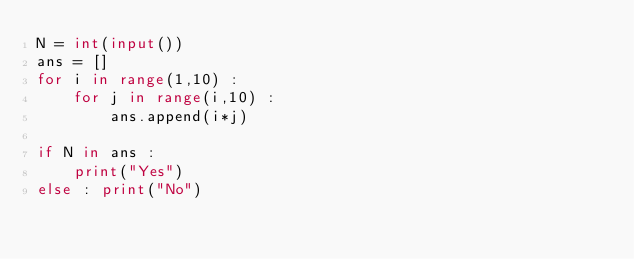<code> <loc_0><loc_0><loc_500><loc_500><_Python_>N = int(input())
ans = []
for i in range(1,10) :
    for j in range(i,10) :
        ans.append(i*j)

if N in ans :
    print("Yes")
else : print("No")
</code> 